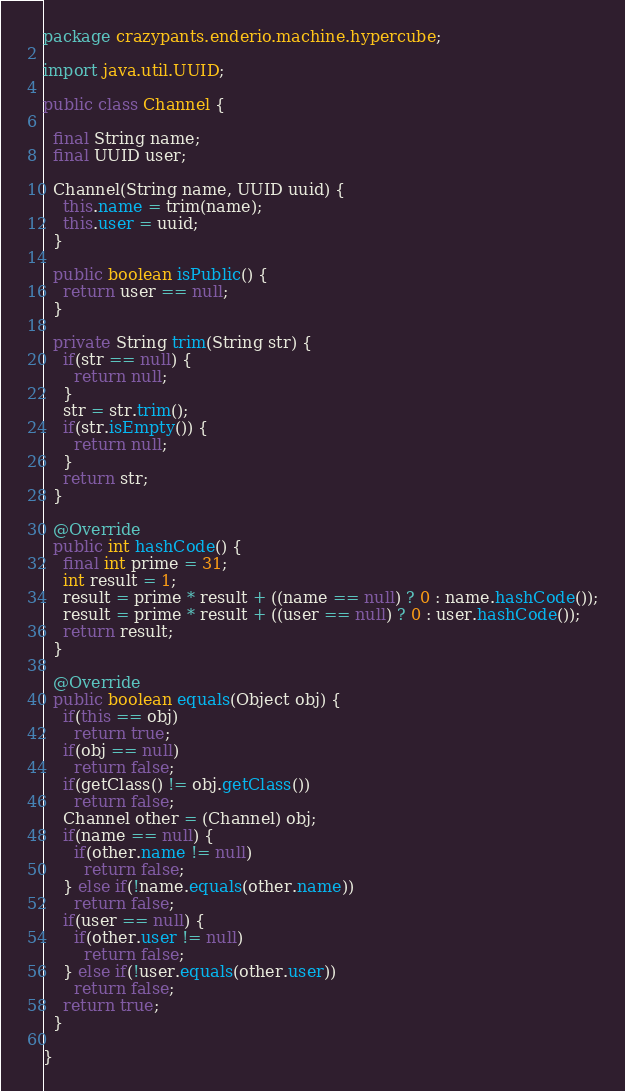<code> <loc_0><loc_0><loc_500><loc_500><_Java_>package crazypants.enderio.machine.hypercube;

import java.util.UUID;

public class Channel {

  final String name;
  final UUID user;

  Channel(String name, UUID uuid) {
    this.name = trim(name);
    this.user = uuid;
  }

  public boolean isPublic() {
    return user == null;
  }

  private String trim(String str) {
    if(str == null) {
      return null;
    }
    str = str.trim();
    if(str.isEmpty()) {
      return null;
    }
    return str;
  }

  @Override
  public int hashCode() {
    final int prime = 31;
    int result = 1;
    result = prime * result + ((name == null) ? 0 : name.hashCode());
    result = prime * result + ((user == null) ? 0 : user.hashCode());
    return result;
  }

  @Override
  public boolean equals(Object obj) {
    if(this == obj)
      return true;
    if(obj == null)
      return false;
    if(getClass() != obj.getClass())
      return false;
    Channel other = (Channel) obj;
    if(name == null) {
      if(other.name != null)
        return false;
    } else if(!name.equals(other.name))
      return false;
    if(user == null) {
      if(other.user != null)
        return false;
    } else if(!user.equals(other.user))
      return false;
    return true;
  }

}
</code> 